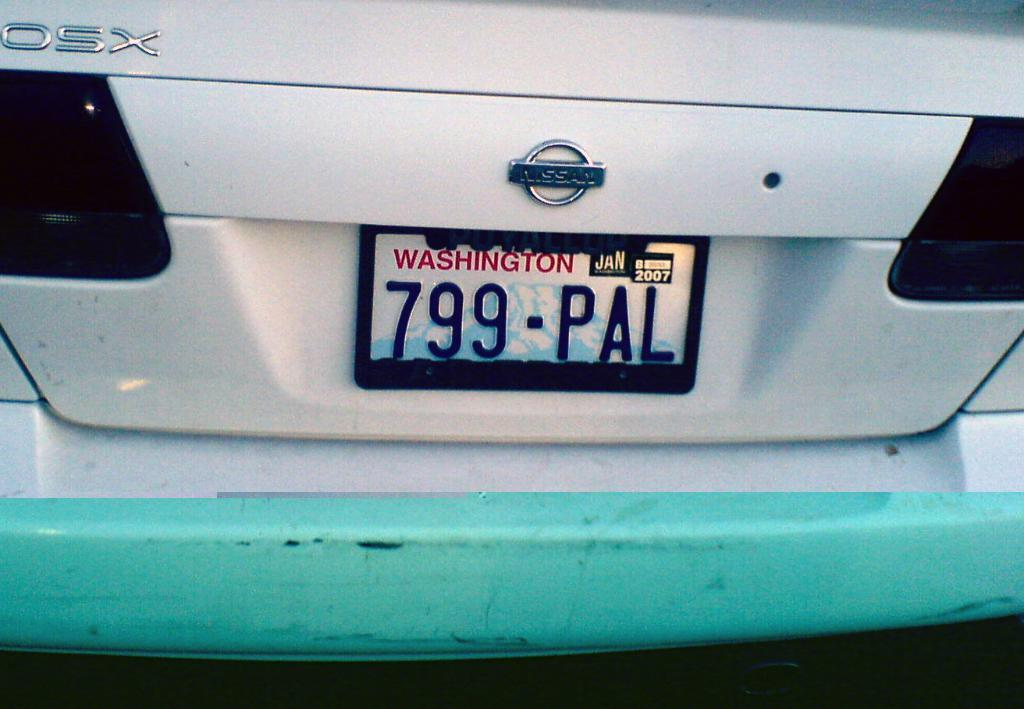<image>
Give a short and clear explanation of the subsequent image. The back of a Nissan car showing its plates. 